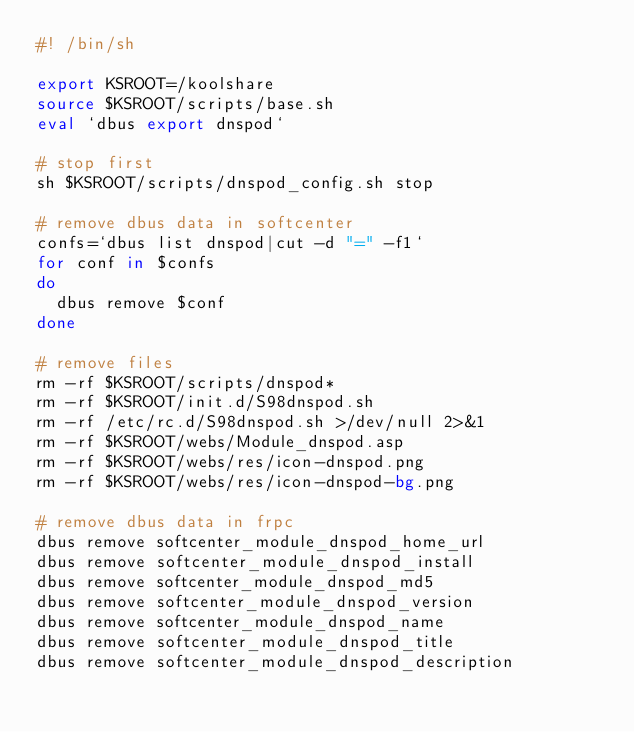Convert code to text. <code><loc_0><loc_0><loc_500><loc_500><_Bash_>#! /bin/sh

export KSROOT=/koolshare
source $KSROOT/scripts/base.sh
eval `dbus export dnspod`

# stop first
sh $KSROOT/scripts/dnspod_config.sh stop

# remove dbus data in softcenter
confs=`dbus list dnspod|cut -d "=" -f1`
for conf in $confs
do
	dbus remove $conf
done

# remove files
rm -rf $KSROOT/scripts/dnspod*
rm -rf $KSROOT/init.d/S98dnspod.sh
rm -rf /etc/rc.d/S98dnspod.sh >/dev/null 2>&1
rm -rf $KSROOT/webs/Module_dnspod.asp
rm -rf $KSROOT/webs/res/icon-dnspod.png
rm -rf $KSROOT/webs/res/icon-dnspod-bg.png

# remove dbus data in frpc
dbus remove softcenter_module_dnspod_home_url
dbus remove softcenter_module_dnspod_install
dbus remove softcenter_module_dnspod_md5
dbus remove softcenter_module_dnspod_version
dbus remove softcenter_module_dnspod_name
dbus remove softcenter_module_dnspod_title
dbus remove softcenter_module_dnspod_description</code> 